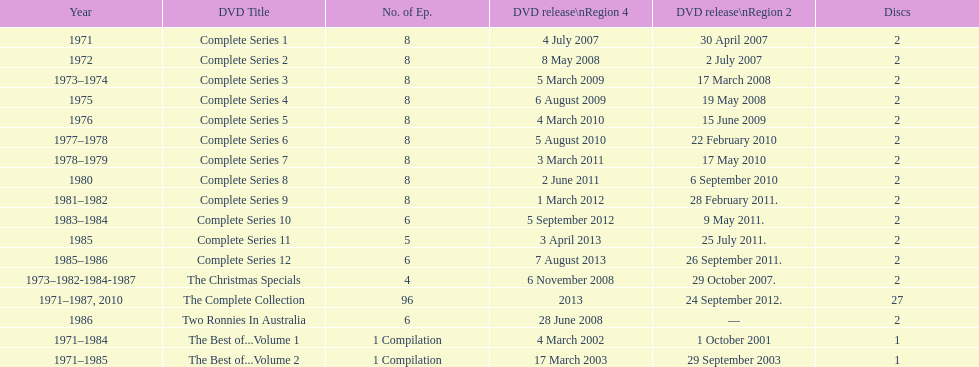The television show "the two ronnies" ran for a total of how many seasons? 12. 